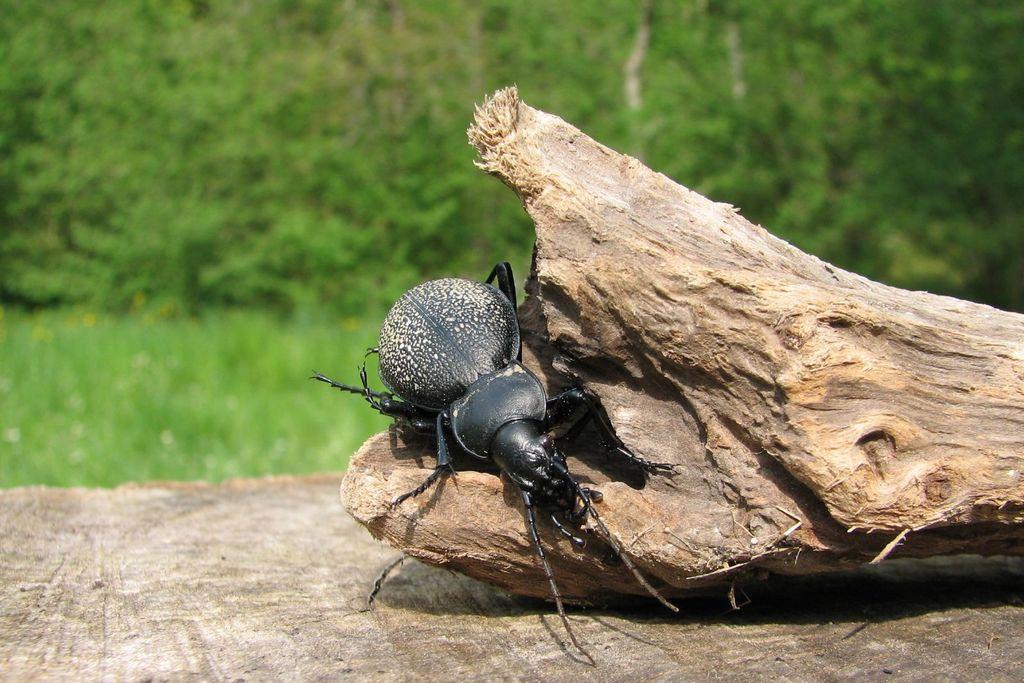In one or two sentences, can you explain what this image depicts? Here we can see an insect on a wooden log on a platform. In the background there are plants and trees. 